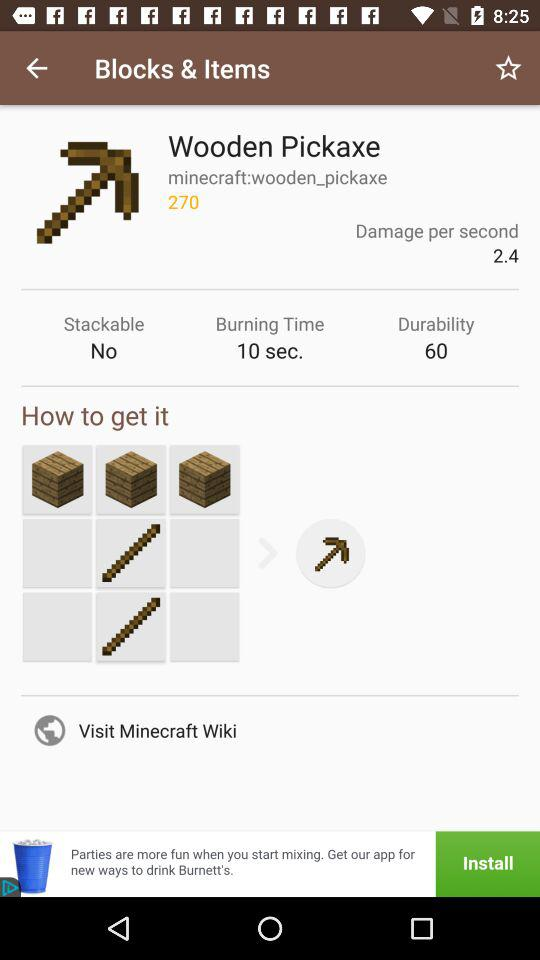What is the damage per second? The damage is 2.4 per second. 